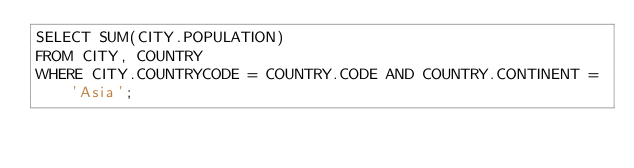Convert code to text. <code><loc_0><loc_0><loc_500><loc_500><_SQL_>SELECT SUM(CITY.POPULATION) 
FROM CITY, COUNTRY
WHERE CITY.COUNTRYCODE = COUNTRY.CODE AND COUNTRY.CONTINENT = 'Asia';
</code> 